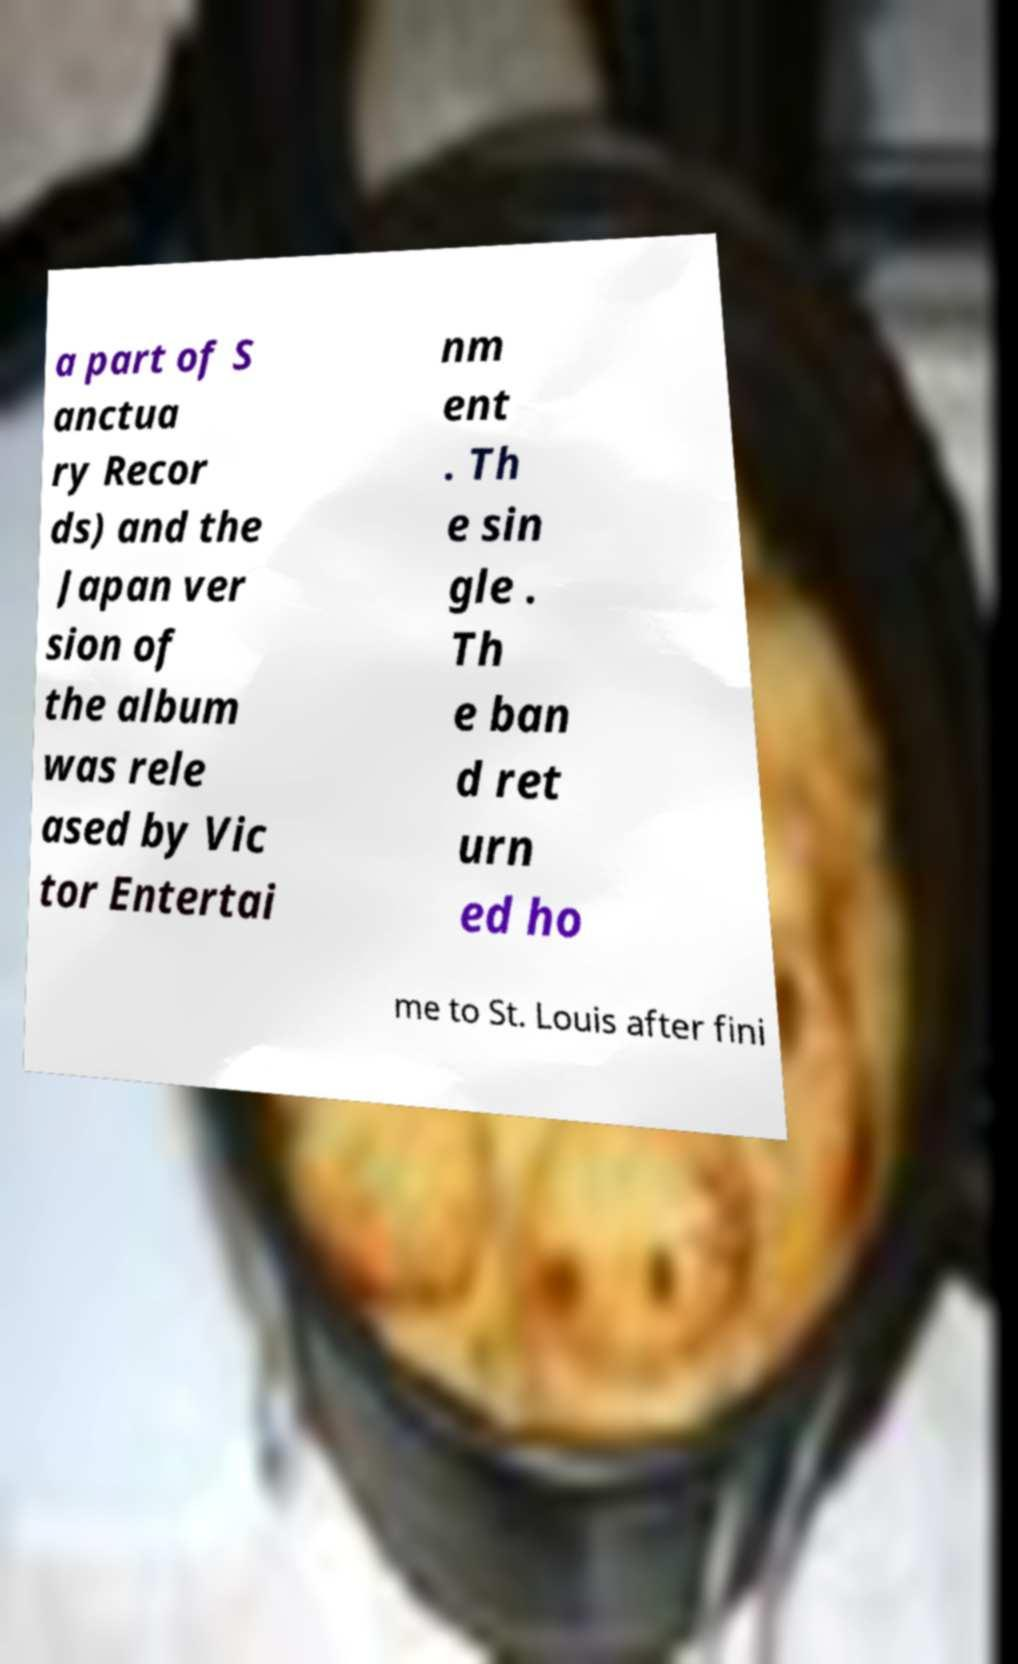For documentation purposes, I need the text within this image transcribed. Could you provide that? a part of S anctua ry Recor ds) and the Japan ver sion of the album was rele ased by Vic tor Entertai nm ent . Th e sin gle . Th e ban d ret urn ed ho me to St. Louis after fini 